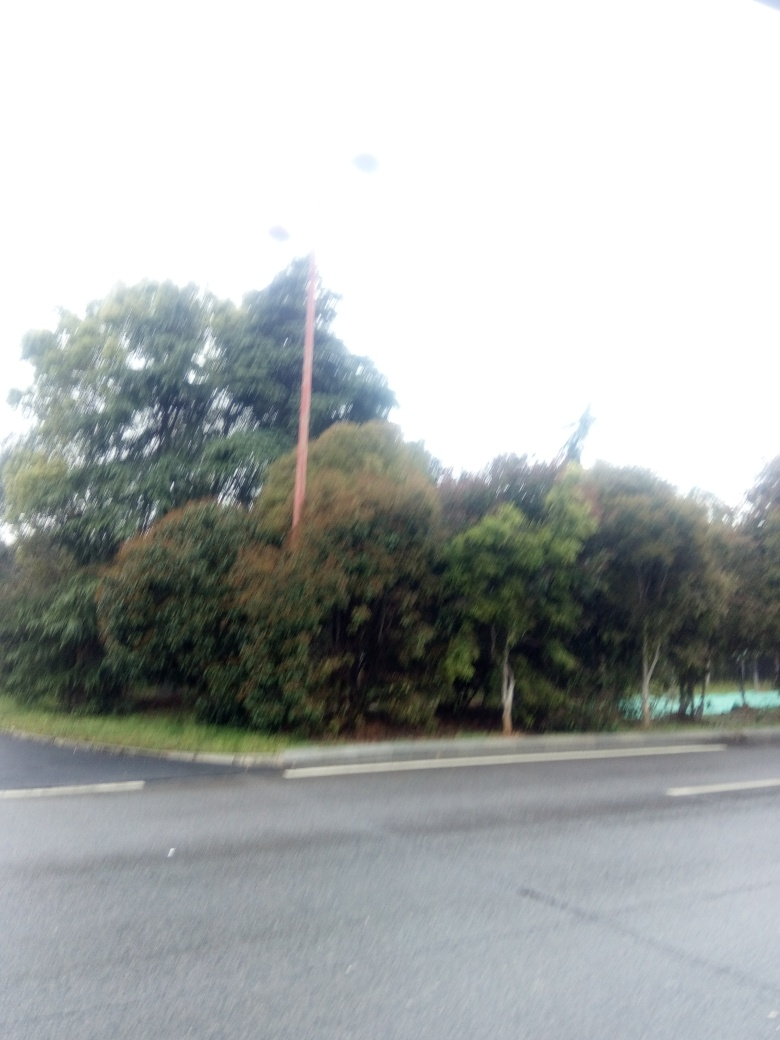Is the color balance accurate in the image? Upon reviewing the image, it appears that the color balance is not optimal. The photograph shows signs of overexposure, making defining features difficult to discern, and the colors are not represented in a true-to-life manner. It might benefit from adjustments to correct the brightness and contrast to bring it closer to how the scene would appear to the human eye. 